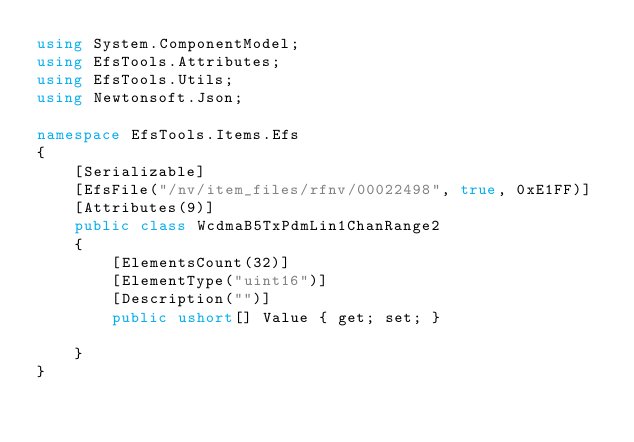Convert code to text. <code><loc_0><loc_0><loc_500><loc_500><_C#_>using System.ComponentModel;
using EfsTools.Attributes;
using EfsTools.Utils;
using Newtonsoft.Json;

namespace EfsTools.Items.Efs
{
    [Serializable]
    [EfsFile("/nv/item_files/rfnv/00022498", true, 0xE1FF)]
    [Attributes(9)]
    public class WcdmaB5TxPdmLin1ChanRange2
    {
        [ElementsCount(32)]
        [ElementType("uint16")]
        [Description("")]
        public ushort[] Value { get; set; }
        
    }
}
</code> 